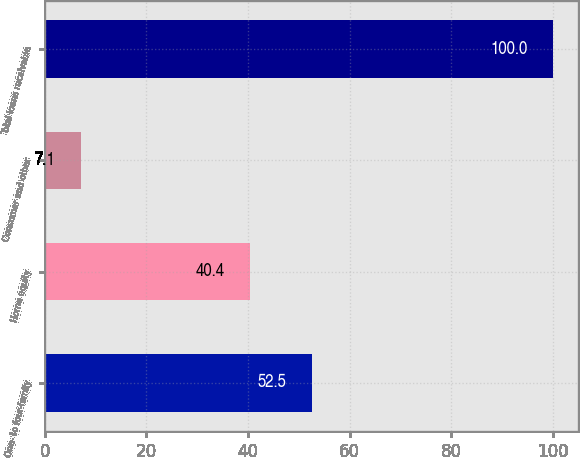Convert chart to OTSL. <chart><loc_0><loc_0><loc_500><loc_500><bar_chart><fcel>One- to four-family<fcel>Home equity<fcel>Consumer and other<fcel>Total loans receivable<nl><fcel>52.5<fcel>40.4<fcel>7.1<fcel>100<nl></chart> 